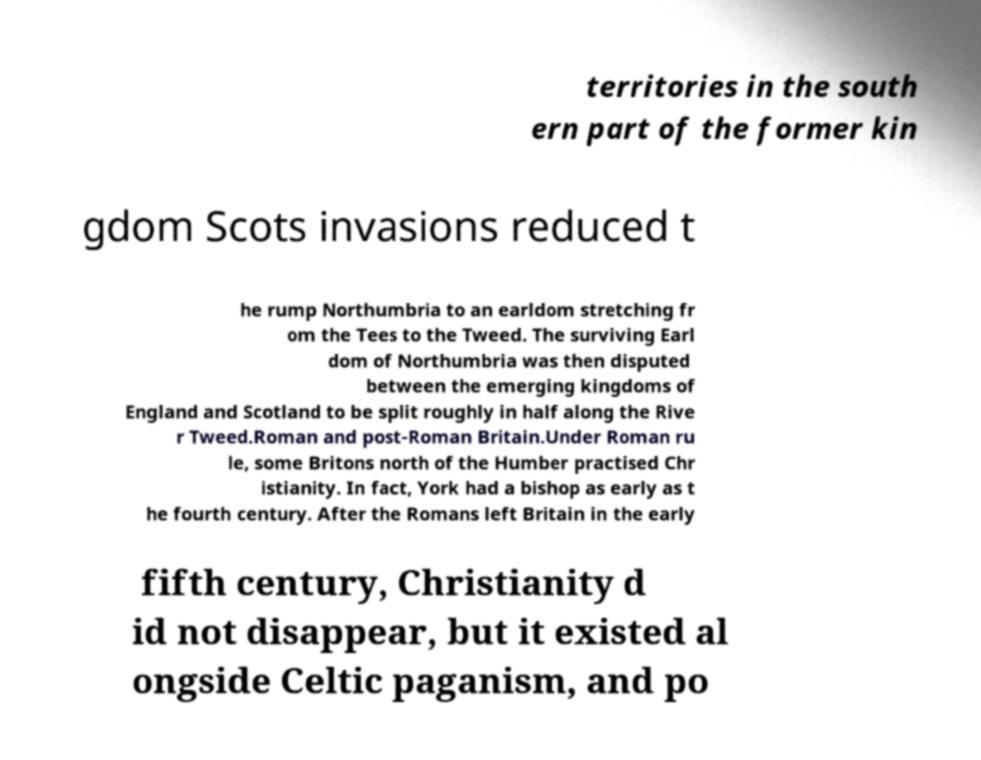There's text embedded in this image that I need extracted. Can you transcribe it verbatim? territories in the south ern part of the former kin gdom Scots invasions reduced t he rump Northumbria to an earldom stretching fr om the Tees to the Tweed. The surviving Earl dom of Northumbria was then disputed between the emerging kingdoms of England and Scotland to be split roughly in half along the Rive r Tweed.Roman and post-Roman Britain.Under Roman ru le, some Britons north of the Humber practised Chr istianity. In fact, York had a bishop as early as t he fourth century. After the Romans left Britain in the early fifth century, Christianity d id not disappear, but it existed al ongside Celtic paganism, and po 